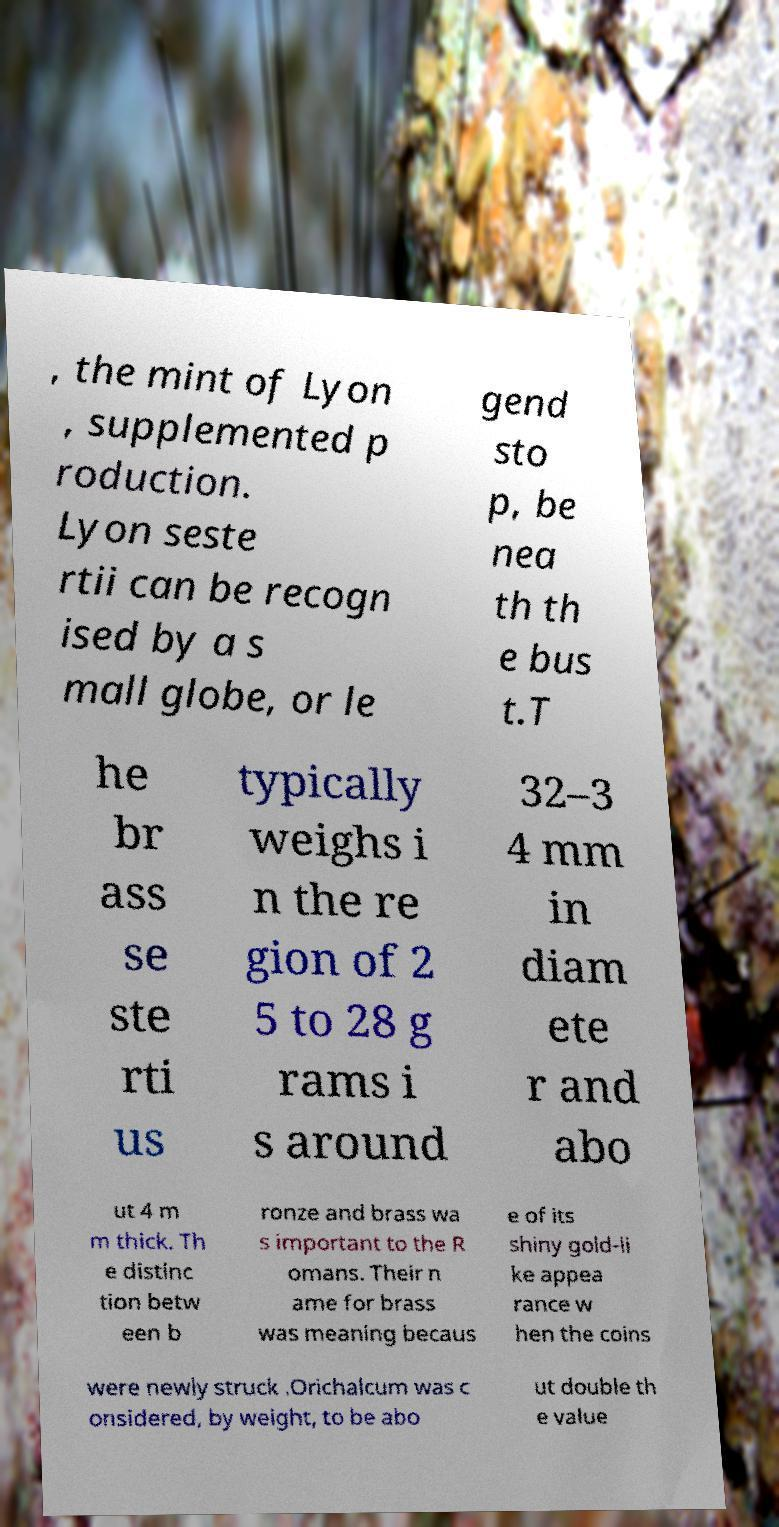What messages or text are displayed in this image? I need them in a readable, typed format. , the mint of Lyon , supplemented p roduction. Lyon seste rtii can be recogn ised by a s mall globe, or le gend sto p, be nea th th e bus t.T he br ass se ste rti us typically weighs i n the re gion of 2 5 to 28 g rams i s around 32–3 4 mm in diam ete r and abo ut 4 m m thick. Th e distinc tion betw een b ronze and brass wa s important to the R omans. Their n ame for brass was meaning becaus e of its shiny gold-li ke appea rance w hen the coins were newly struck .Orichalcum was c onsidered, by weight, to be abo ut double th e value 